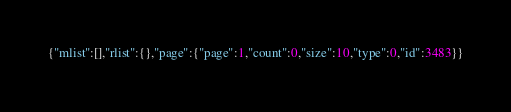<code> <loc_0><loc_0><loc_500><loc_500><_JavaScript_>{"mlist":[],"rlist":{},"page":{"page":1,"count":0,"size":10,"type":0,"id":3483}}</code> 